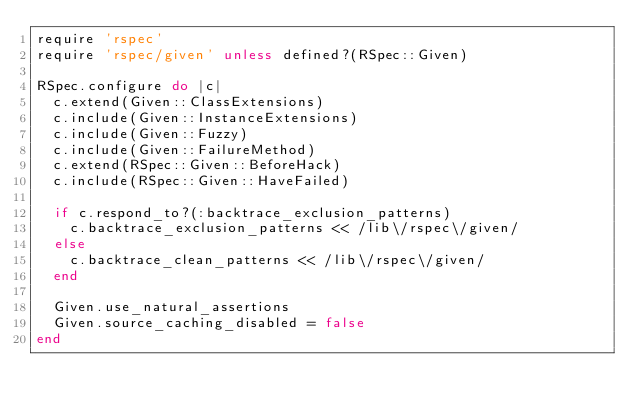Convert code to text. <code><loc_0><loc_0><loc_500><loc_500><_Ruby_>require 'rspec'
require 'rspec/given' unless defined?(RSpec::Given)

RSpec.configure do |c|
  c.extend(Given::ClassExtensions)
  c.include(Given::InstanceExtensions)
  c.include(Given::Fuzzy)
  c.include(Given::FailureMethod)
  c.extend(RSpec::Given::BeforeHack)
  c.include(RSpec::Given::HaveFailed)

  if c.respond_to?(:backtrace_exclusion_patterns)
    c.backtrace_exclusion_patterns << /lib\/rspec\/given/
  else
    c.backtrace_clean_patterns << /lib\/rspec\/given/
  end

  Given.use_natural_assertions
  Given.source_caching_disabled = false
end
</code> 